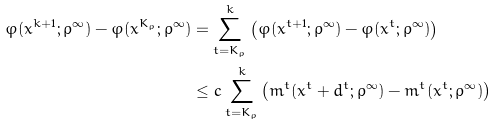Convert formula to latex. <formula><loc_0><loc_0><loc_500><loc_500>\varphi ( x ^ { k + 1 } ; \rho ^ { \infty } ) - \varphi ( x ^ { K _ { \rho } } ; \rho ^ { \infty } ) & = \sum _ { t = K _ { \rho } } ^ { k } \left ( \varphi ( x ^ { t + 1 } ; \rho ^ { \infty } ) - \varphi ( x ^ { t } ; \rho ^ { \infty } ) \right ) \\ & \leq c \sum _ { t = K _ { \rho } } ^ { k } \left ( m ^ { t } ( x ^ { t } + d ^ { t } ; \rho ^ { \infty } ) - m ^ { t } ( x ^ { t } ; \rho ^ { \infty } ) \right )</formula> 